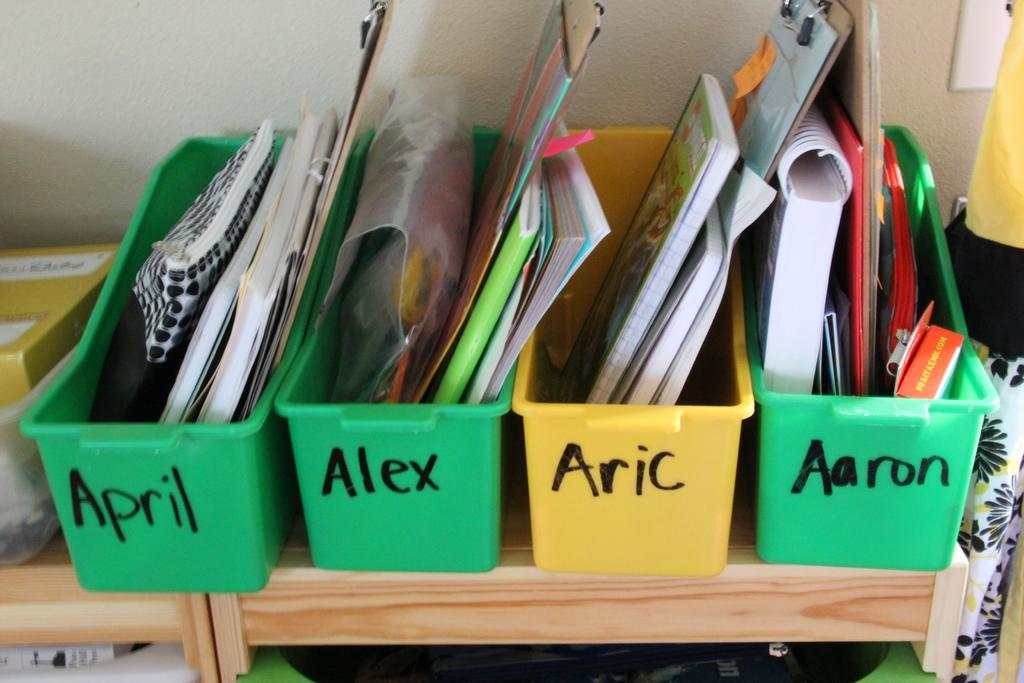<image>
Give a short and clear explanation of the subsequent image. Four bins are lined up with names on them including April and Alex. 